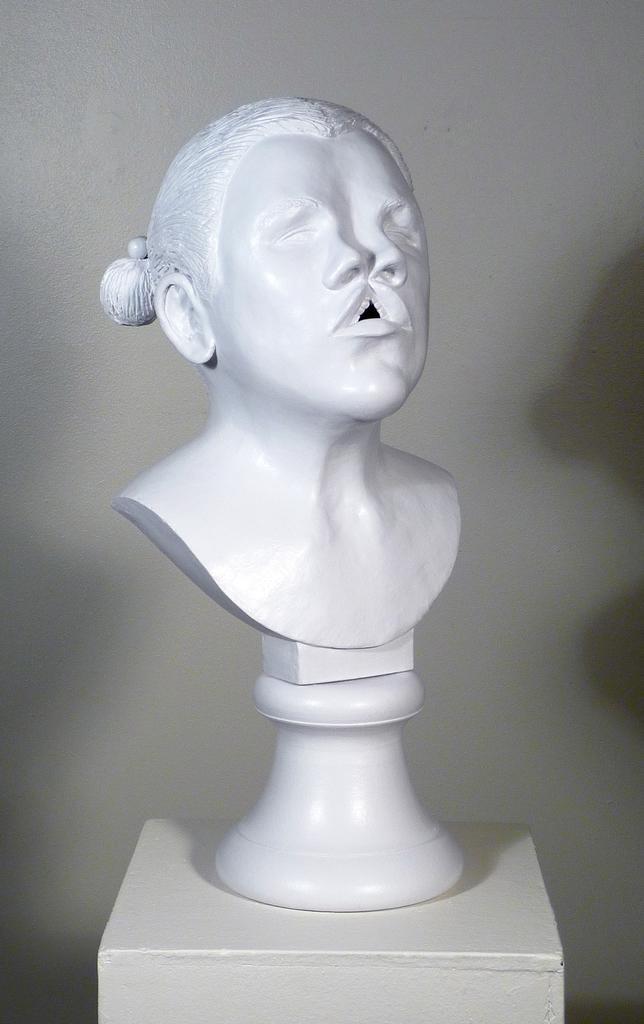In one or two sentences, can you explain what this image depicts? In this image, we can see a sculpture. 